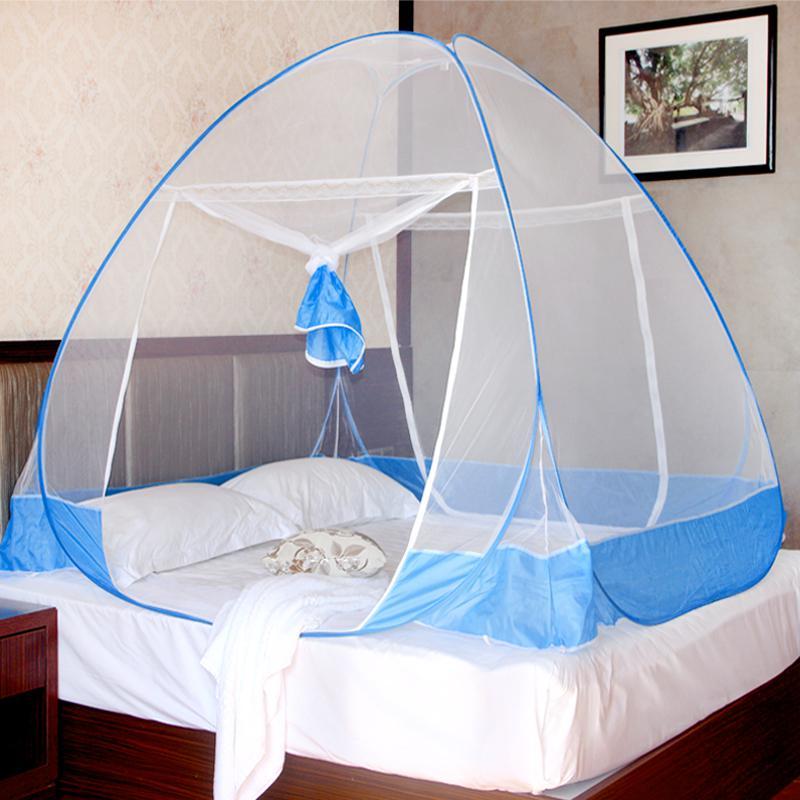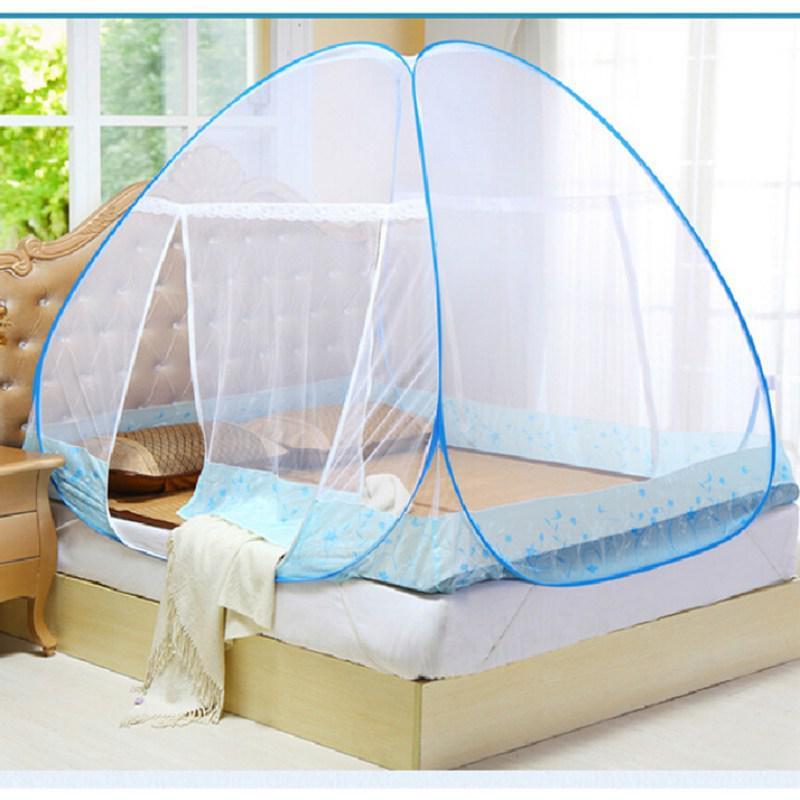The first image is the image on the left, the second image is the image on the right. Examine the images to the left and right. Is the description "The style and shape of bed netting is the same in both images." accurate? Answer yes or no. Yes. The first image is the image on the left, the second image is the image on the right. Examine the images to the left and right. Is the description "One of the images of mosquito nets has a round top with silver flowers on it." accurate? Answer yes or no. No. 